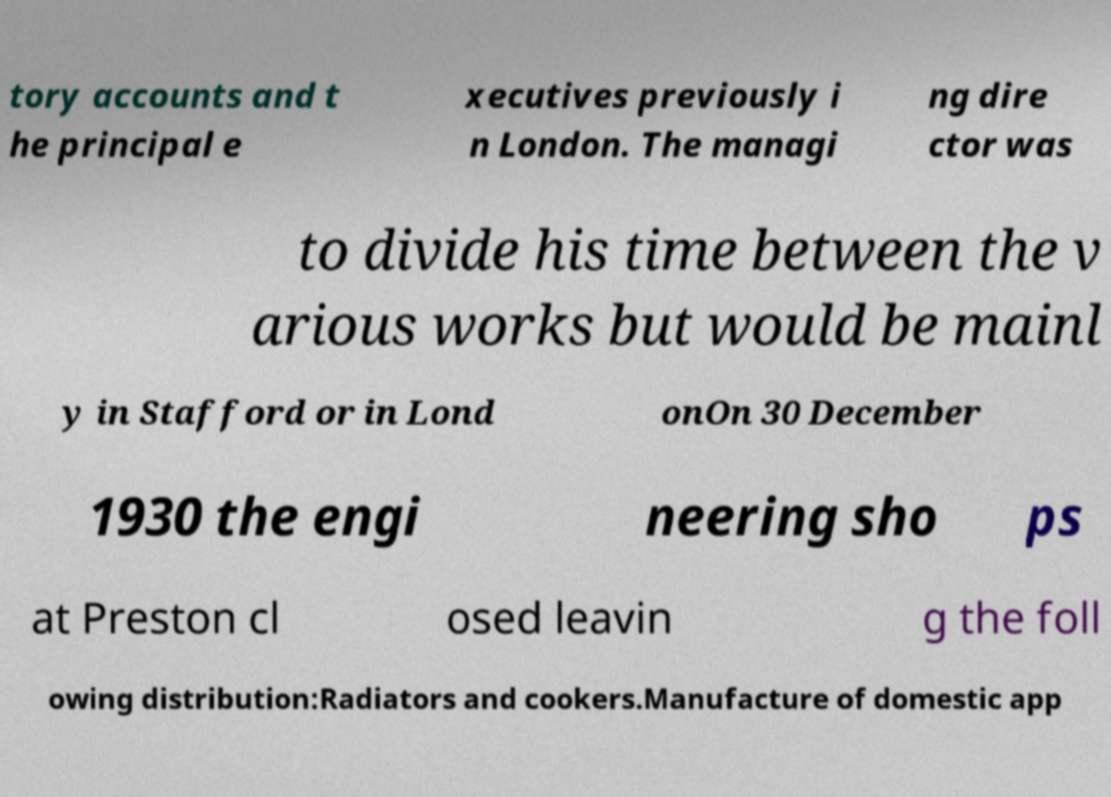Please read and relay the text visible in this image. What does it say? tory accounts and t he principal e xecutives previously i n London. The managi ng dire ctor was to divide his time between the v arious works but would be mainl y in Stafford or in Lond onOn 30 December 1930 the engi neering sho ps at Preston cl osed leavin g the foll owing distribution:Radiators and cookers.Manufacture of domestic app 